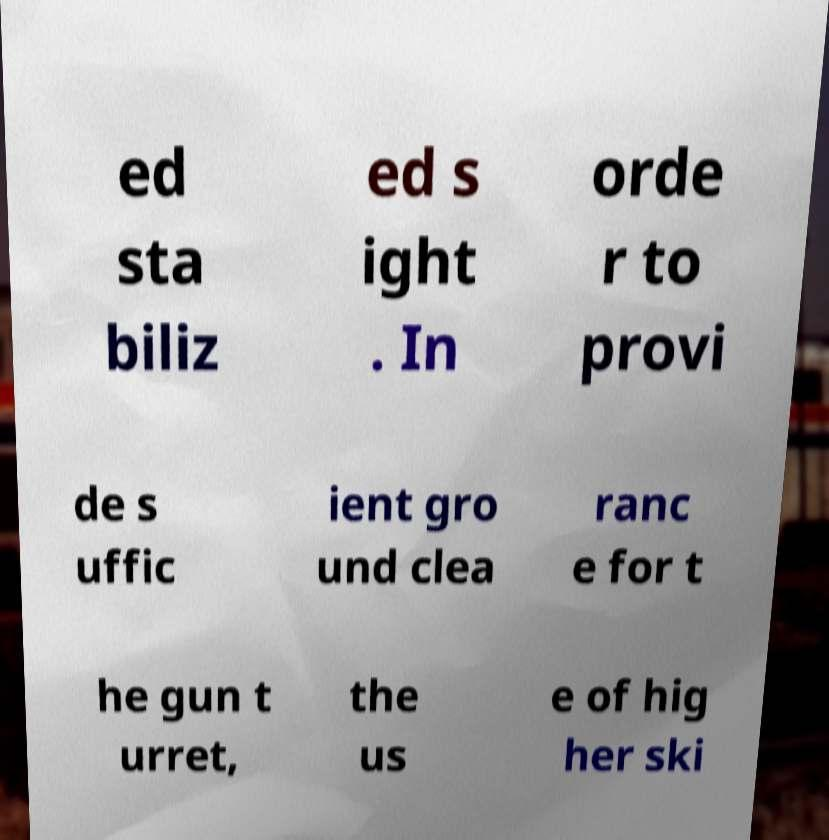Could you extract and type out the text from this image? ed sta biliz ed s ight . In orde r to provi de s uffic ient gro und clea ranc e for t he gun t urret, the us e of hig her ski 